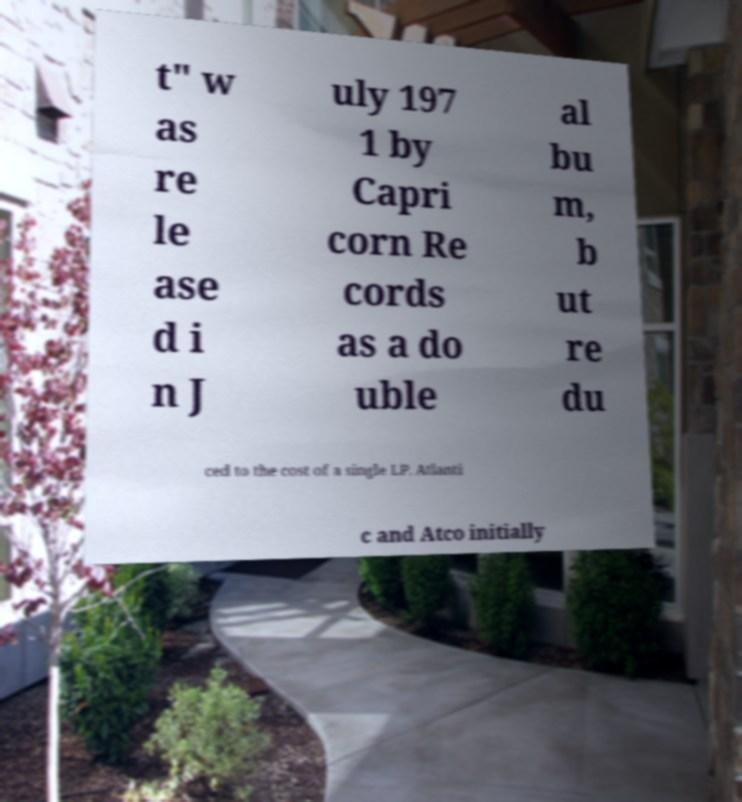For documentation purposes, I need the text within this image transcribed. Could you provide that? t" w as re le ase d i n J uly 197 1 by Capri corn Re cords as a do uble al bu m, b ut re du ced to the cost of a single LP. Atlanti c and Atco initially 